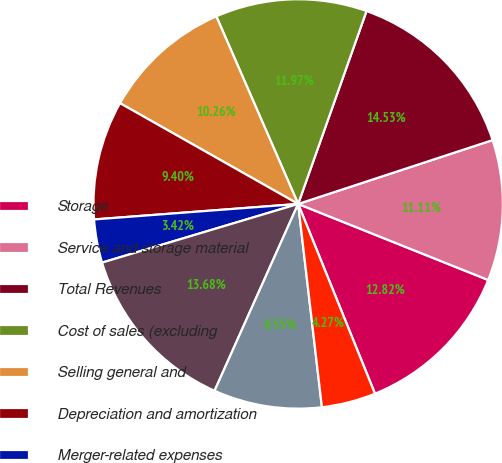<chart> <loc_0><loc_0><loc_500><loc_500><pie_chart><fcel>Storage<fcel>Service and storage material<fcel>Total Revenues<fcel>Cost of sales (excluding<fcel>Selling general and<fcel>Depreciation and amortization<fcel>Merger-related expenses<fcel>Total Operating Expenses<fcel>Operating Income<fcel>(Loss) Income from Continuing<nl><fcel>12.82%<fcel>11.11%<fcel>14.53%<fcel>11.97%<fcel>10.26%<fcel>9.4%<fcel>3.42%<fcel>13.68%<fcel>8.55%<fcel>4.27%<nl></chart> 